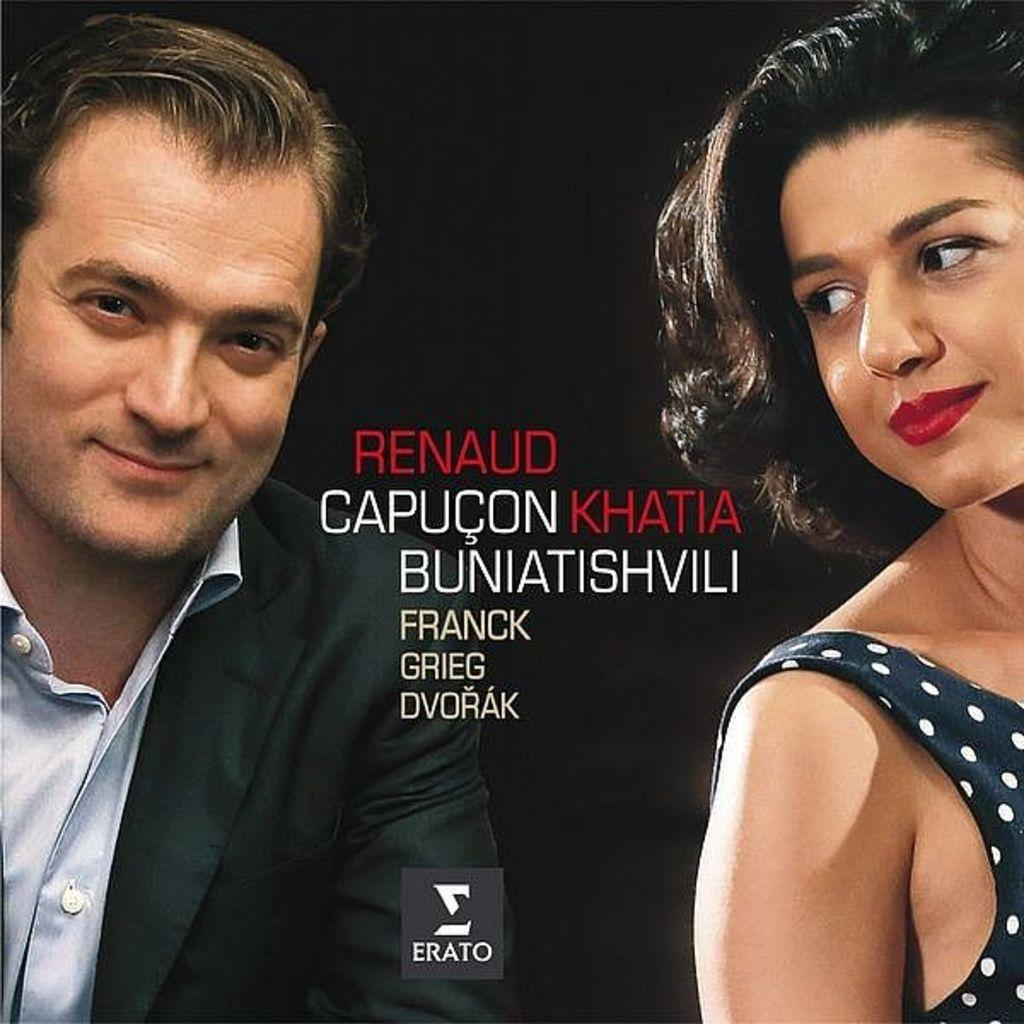How many people are present in the image? There is a man and a woman in the image. What can be seen in the image besides the people? There is some text in the image. What is the color of the background in the image? The background of the image is dark. What type of vegetable is the man holding in the image? There is no vegetable present in the image; the man and woman are not holding any objects. 